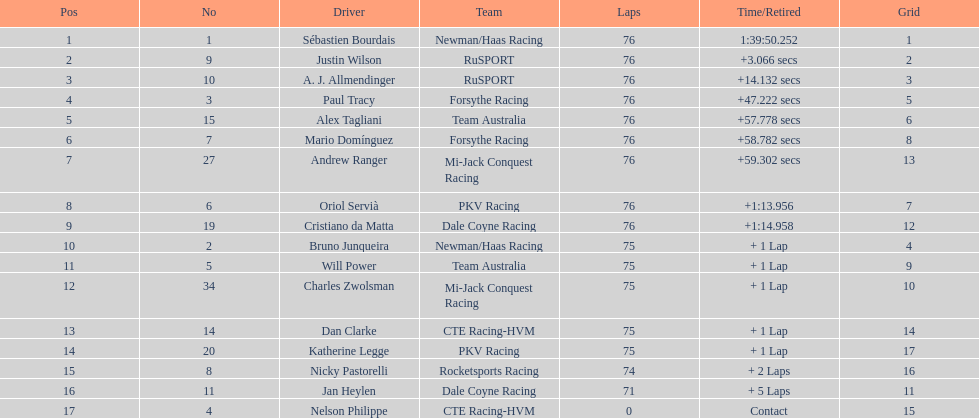Which drivers completed all 76 laps? Sébastien Bourdais, Justin Wilson, A. J. Allmendinger, Paul Tracy, Alex Tagliani, Mario Domínguez, Andrew Ranger, Oriol Servià, Cristiano da Matta. Of these drivers, which ones finished less than a minute behind first place? Paul Tracy, Alex Tagliani, Mario Domínguez, Andrew Ranger. Of these drivers, which ones finished with a time less than 50 seconds behind first place? Justin Wilson, A. J. Allmendinger, Paul Tracy. Of these three drivers, who finished last? Paul Tracy. 